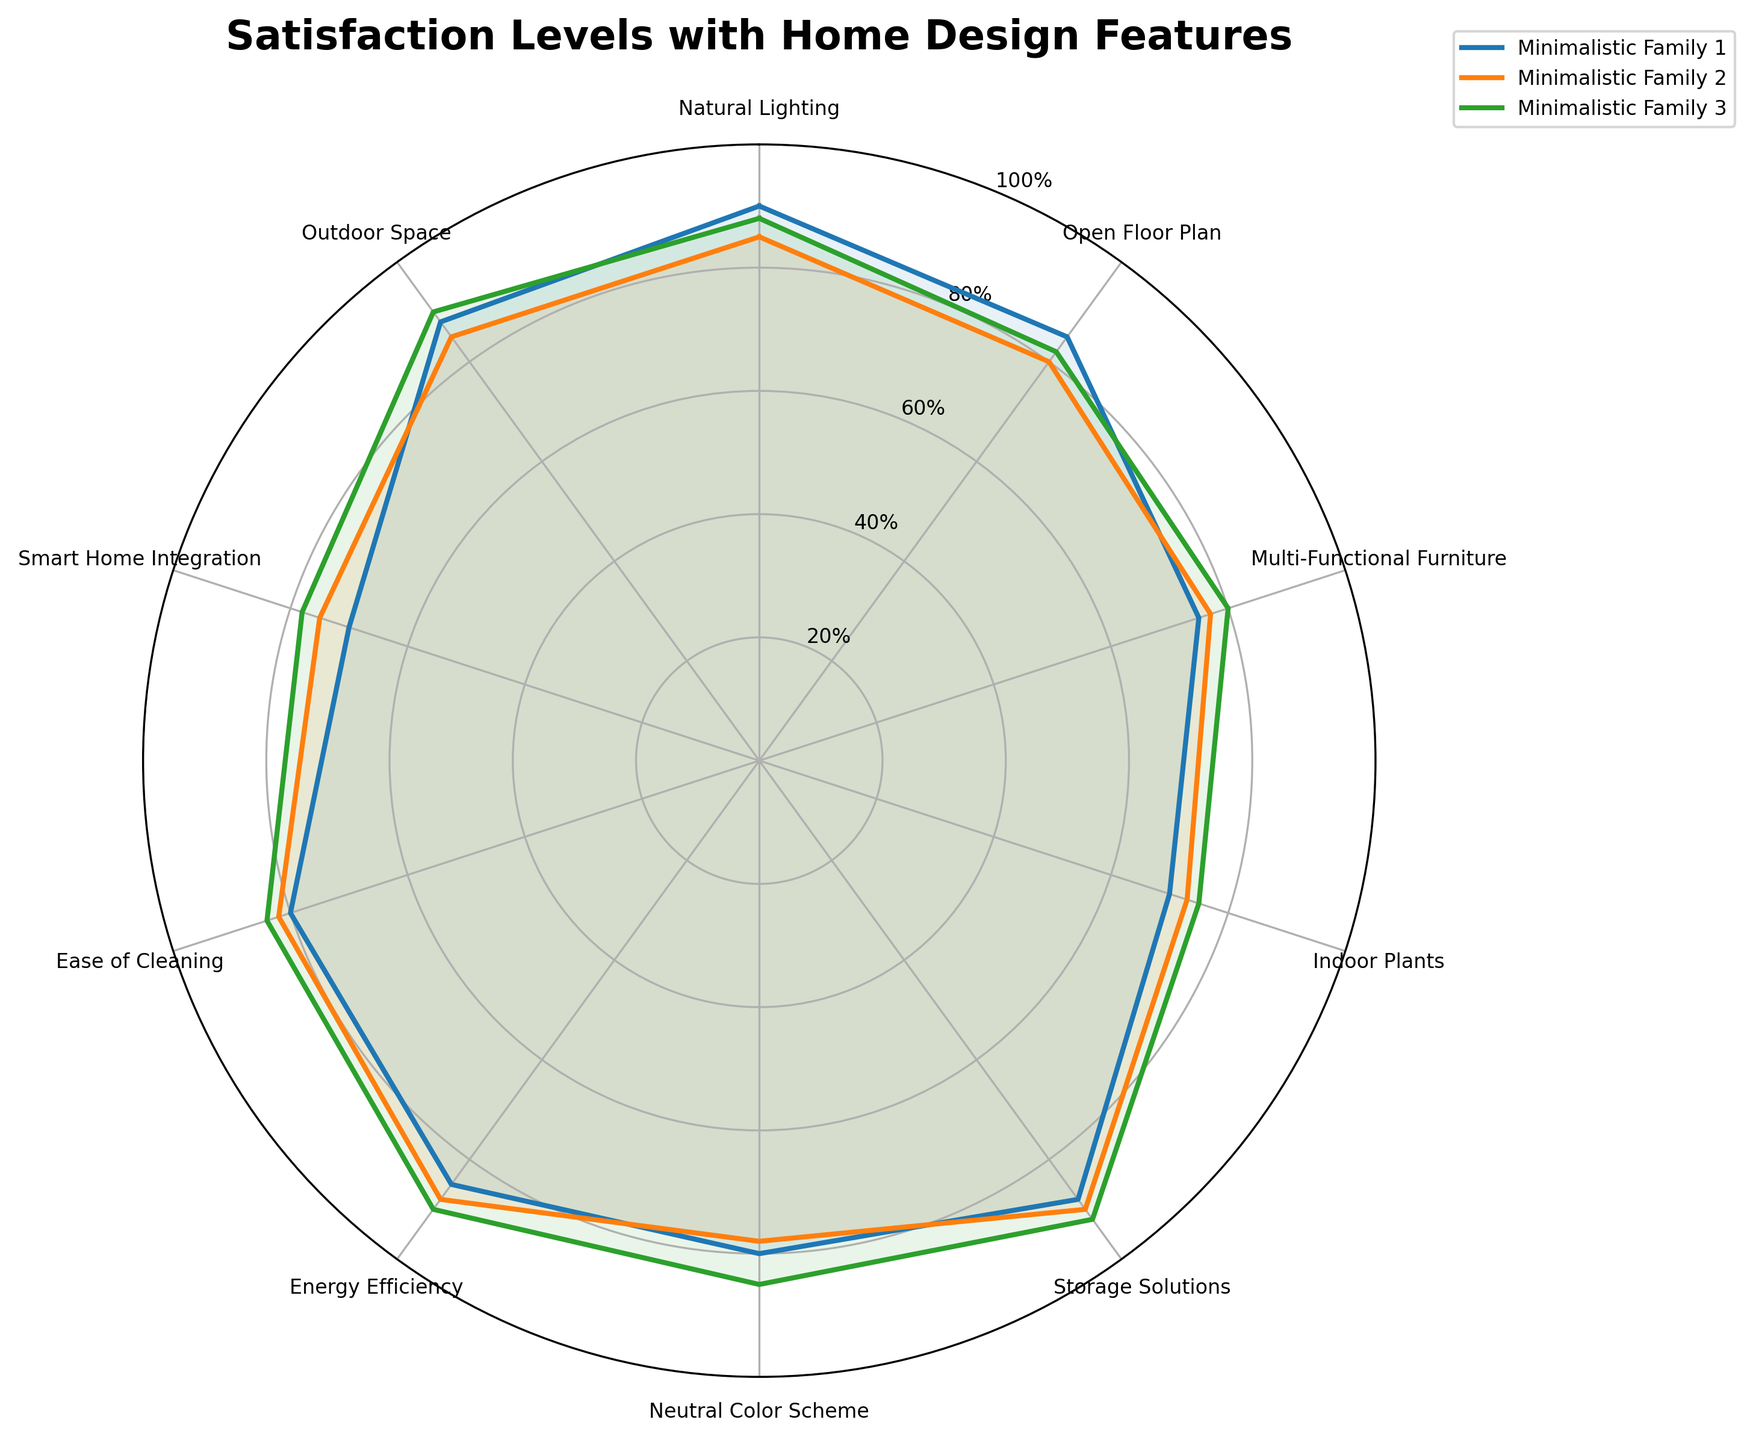Which group has the highest satisfaction level with Natural Lighting? By examining the radar chart, we check the points corresponding to "Natural Lighting" and identify the group that reaches the highest value. In this case, the group "Minimalistic Family 1" has the highest value with a score of 90.
Answer: Minimalistic Family 1 What is the average satisfaction level for Indoor Plants across all groups? We sum up the satisfaction levels for "Indoor Plants" across all three groups (70, 73, and 75). Then, divide by the number of groups, which is 3. The sum is 70 + 73 + 75 = 218. Therefore, the average is 218 / 3 = 72.67.
Answer: 72.67 How does the satisfaction level for Storage Solutions differ between Minimalistic Family 2 and Minimalistic Family 3? We subtract the satisfaction level of "Minimalistic Family 2" from that of "Minimalistic Family 3" for "Storage Solutions." The values are 90 and 92 respectively. The difference is 92 - 90 = 2.
Answer: 2 Which feature has the lowest satisfaction level for Minimalistic Family 1? By inspecting the radar chart, locate the feature with the lowest value for "Minimalistic Family 1." The feature with the lowest value is "Indoor Plants," which has a satisfaction level of 70.
Answer: Indoor Plants Between Open Floor Plan and Smart Home Integration, which feature has higher satisfaction levels on average across all groups? We calculate the average satisfaction levels for both features. For "Open Floor Plan," the values are 85, 80, and 82, with an average of (85 + 80 + 82) / 3 = 82.33. For "Smart Home Integration," the values are 70, 75, and 78, with an average of (70 + 75 + 78) / 3 = 74.33. Therefore, "Open Floor Plan" has a higher average satisfaction level.
Answer: Open Floor Plan What is the difference in satisfaction levels between the highest and lowest scoring features for Minimalistic Family 3? We locate the highest and lowest values for "Minimalistic Family 3." The highest value is for "Storage Solutions" at 92, and the lowest is for "Indoor Plants" at 75. The difference is 92 - 75 = 17.
Answer: 17 How many features have a satisfaction level of at least 80 for Minimalistic Family 1? We count the number of features in “Minimalistic Family 1” that have a satisfaction level of 80 or above. These features are “Natural Lighting” (90), “Open Floor Plan” (85), “Storage Solutions” (88), "Neutral Color Scheme" (80), "Energy Efficiency" (85), "Ease of Cleaning" (80), and “Outdoor Space” (88). There are 7 such features.
Answer: 7 Is there any feature where all Minimalistic Families have the same satisfaction level? By examining all the features on the radar chart, we check if any feature has identical values across all three families. There is no feature with all identical satisfaction levels among the three groups.
Answer: No 